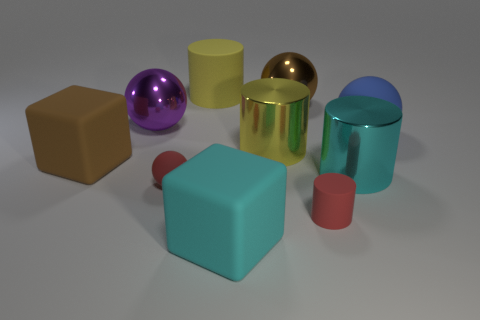There is a large rubber thing that is on the right side of the large purple sphere and in front of the large rubber ball; what is its color?
Make the answer very short. Cyan. There is a large yellow object that is behind the purple ball; is there a large brown rubber block to the right of it?
Give a very brief answer. No. Are there an equal number of large cylinders in front of the brown rubber thing and cyan metallic spheres?
Offer a very short reply. No. There is a large cylinder to the right of the large brown metal thing behind the blue ball; what number of big yellow rubber cylinders are to the left of it?
Your response must be concise. 1. Are there any green balls of the same size as the brown sphere?
Keep it short and to the point. No. Is the number of yellow matte cylinders in front of the large matte cylinder less than the number of large cyan matte objects?
Ensure brevity in your answer.  Yes. The big sphere that is on the left side of the yellow thing that is on the right side of the large yellow cylinder that is behind the blue thing is made of what material?
Offer a terse response. Metal. Are there more purple balls in front of the big cyan matte block than yellow rubber things in front of the purple sphere?
Ensure brevity in your answer.  No. What number of metallic things are either tiny red things or brown things?
Provide a short and direct response. 1. What is the shape of the small matte thing that is the same color as the tiny rubber ball?
Your answer should be very brief. Cylinder. 